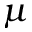Convert formula to latex. <formula><loc_0><loc_0><loc_500><loc_500>\mu</formula> 